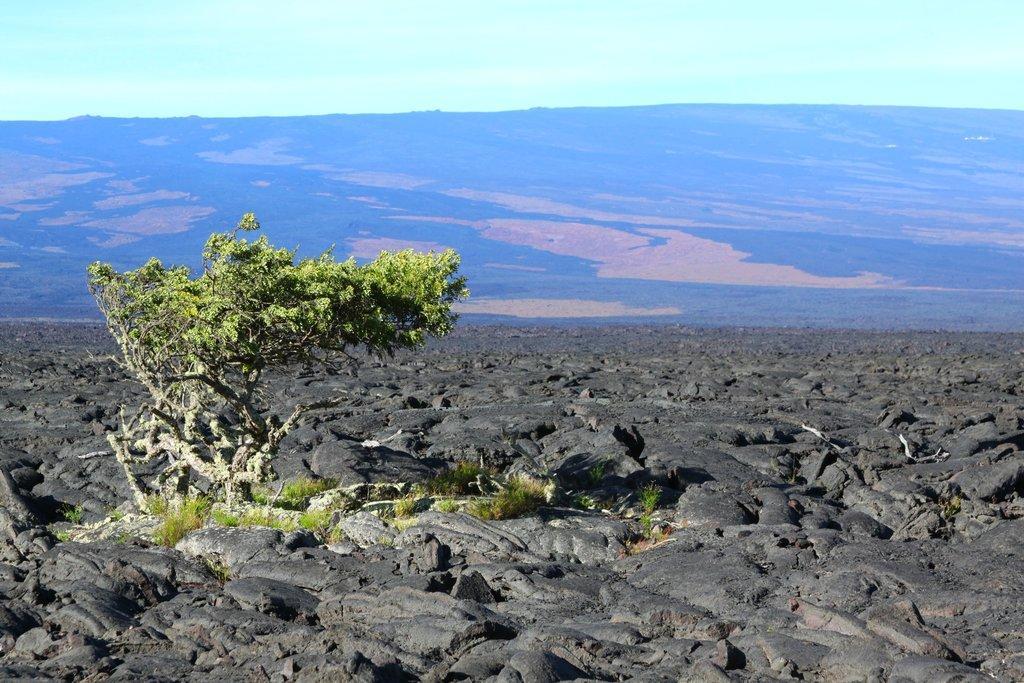In one or two sentences, can you explain what this image depicts? At the bottom we can see rocks, trees and grass. In the background there is a mountain and clouds in the sky. 